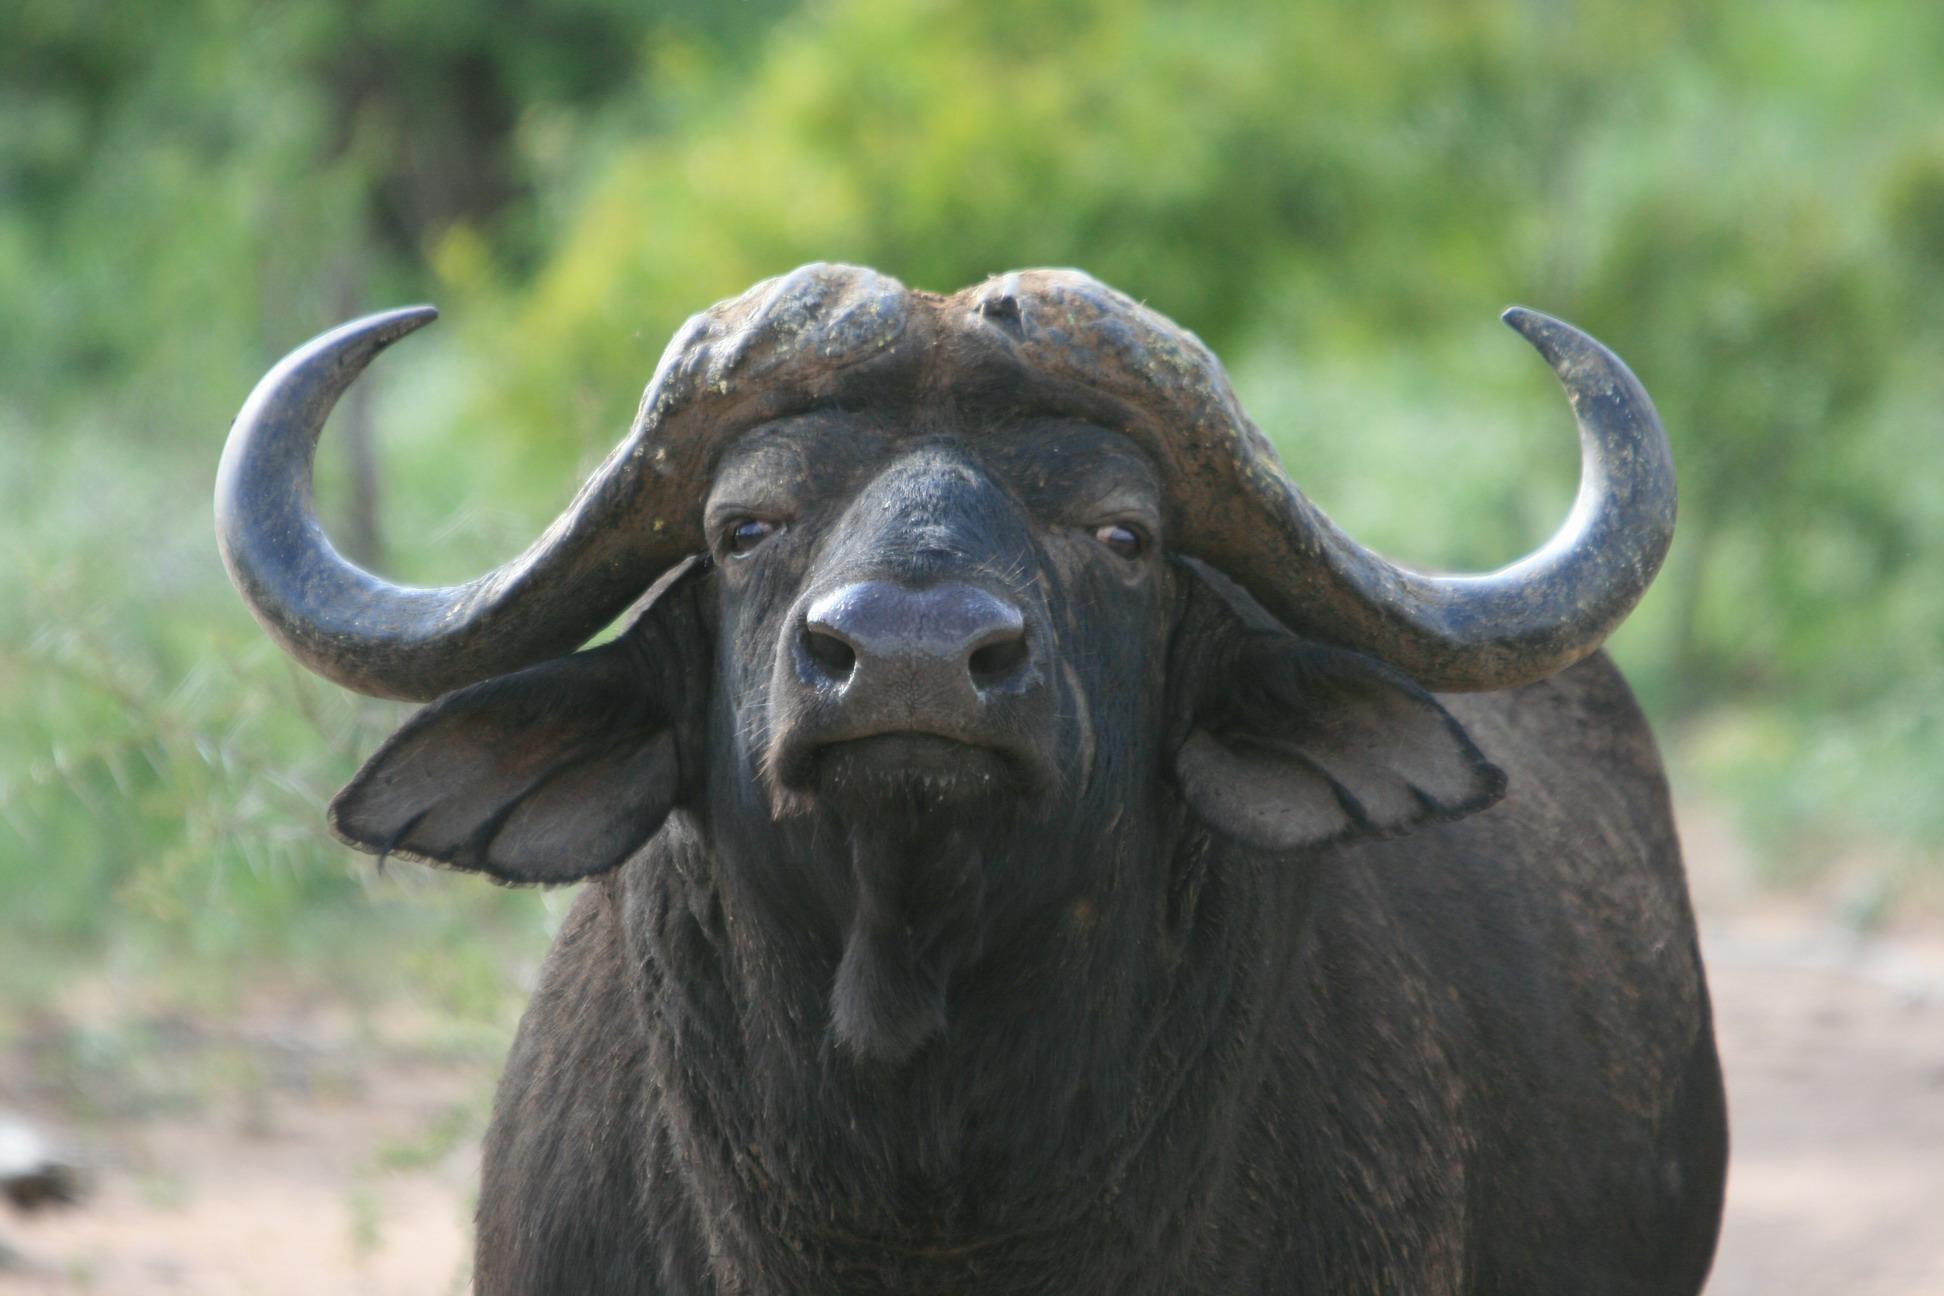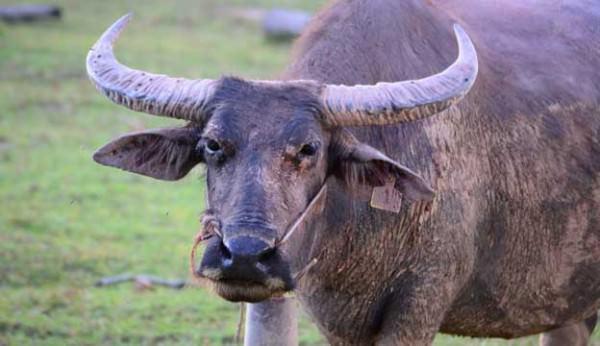The first image is the image on the left, the second image is the image on the right. For the images shown, is this caption "In at least one image the oxen is partially submerged, past the legs, in water." true? Answer yes or no. No. 